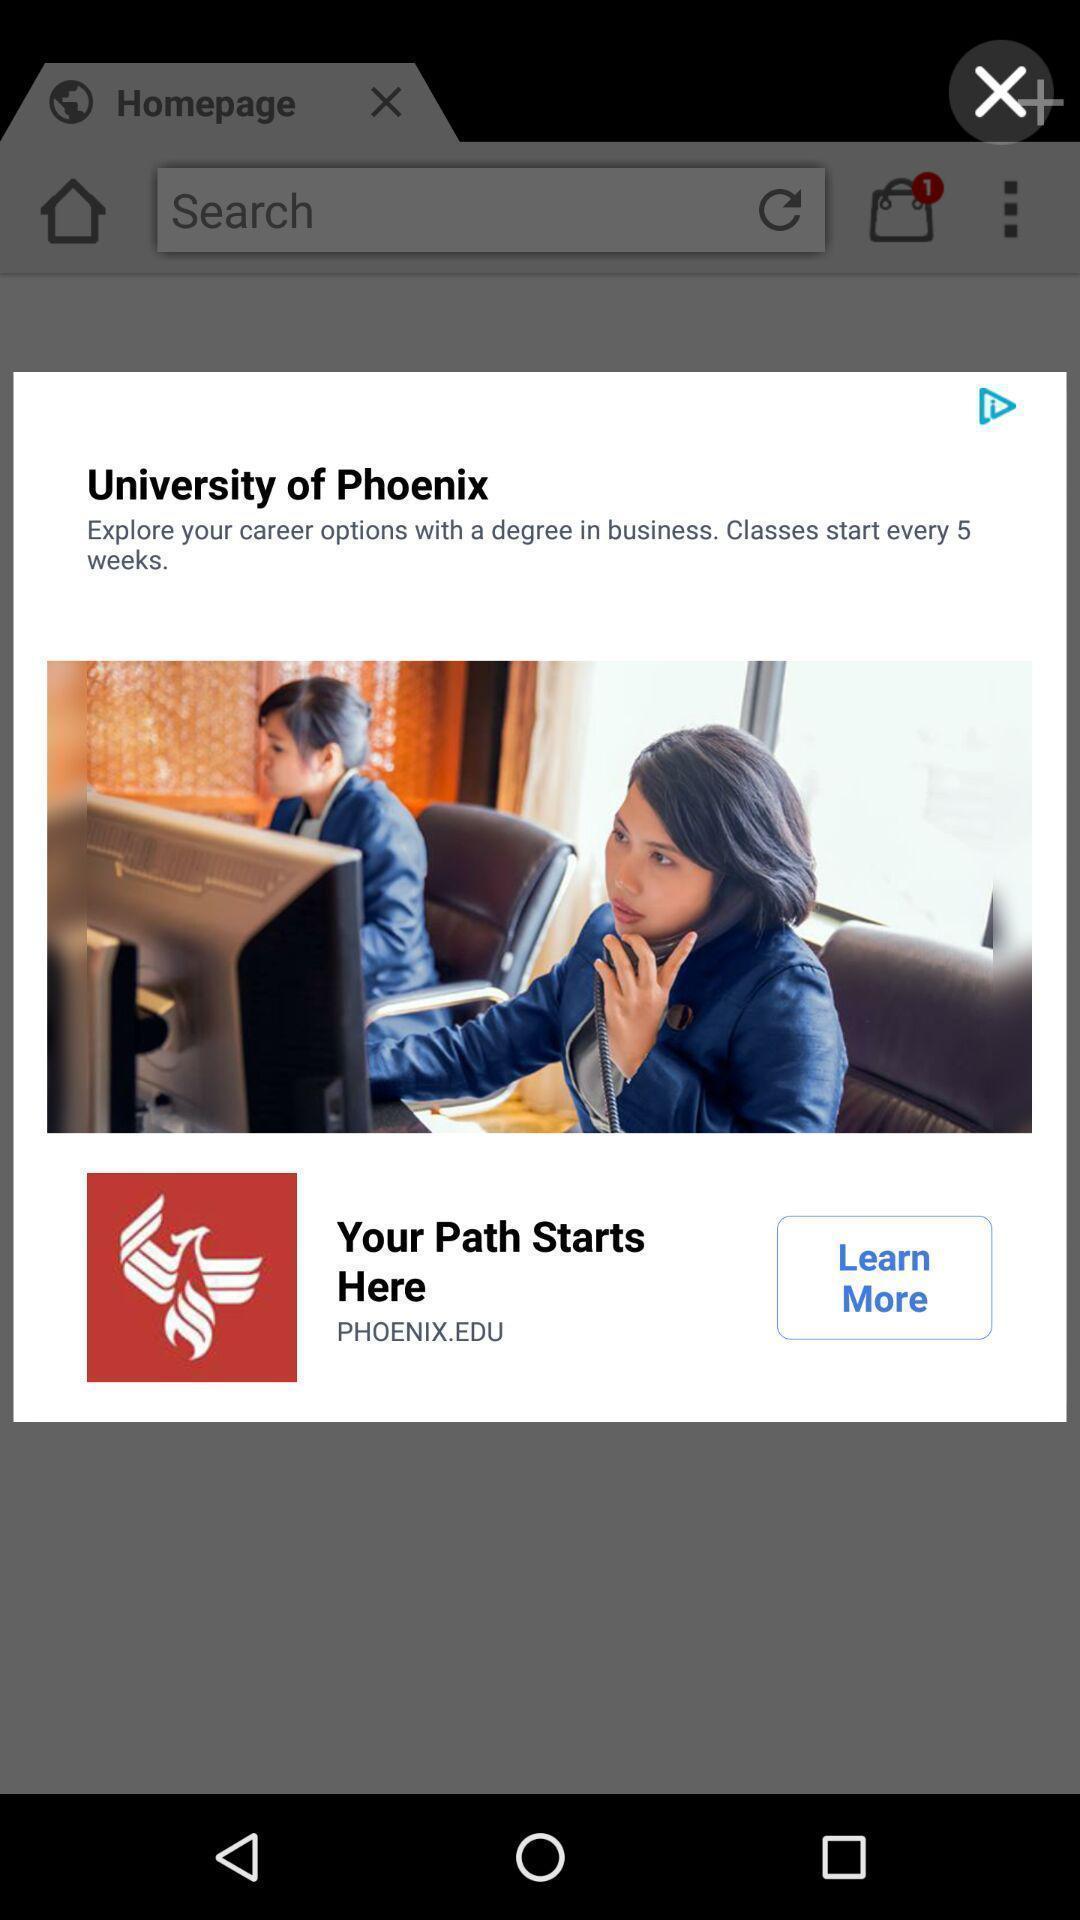Summarize the information in this screenshot. Pop-up showing an advertisement for university. 